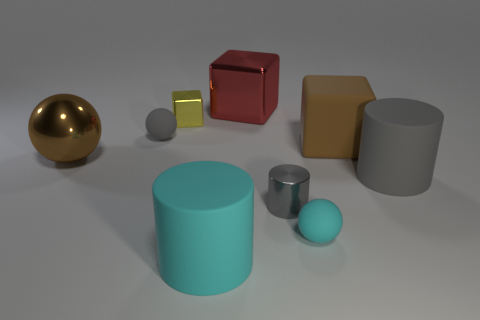Subtract all cubes. How many objects are left? 6 Subtract all brown things. Subtract all large gray objects. How many objects are left? 6 Add 6 metal blocks. How many metal blocks are left? 8 Add 5 gray rubber cylinders. How many gray rubber cylinders exist? 6 Subtract 1 brown spheres. How many objects are left? 8 